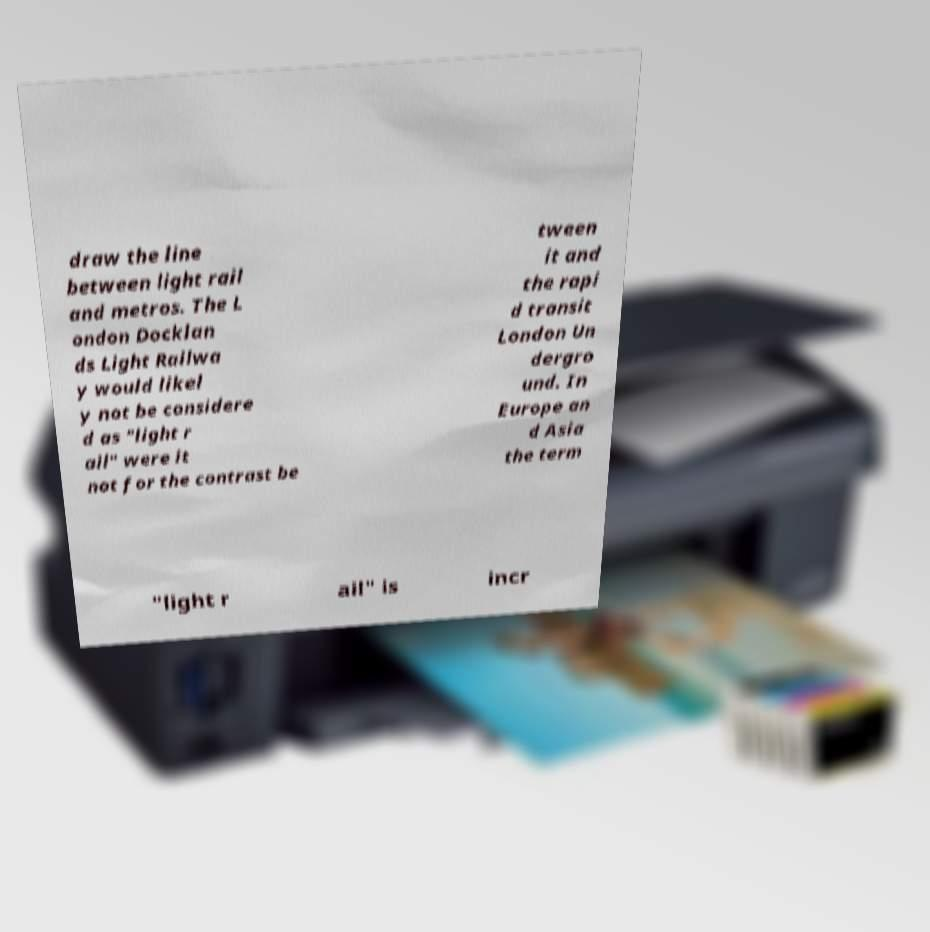There's text embedded in this image that I need extracted. Can you transcribe it verbatim? draw the line between light rail and metros. The L ondon Docklan ds Light Railwa y would likel y not be considere d as "light r ail" were it not for the contrast be tween it and the rapi d transit London Un dergro und. In Europe an d Asia the term "light r ail" is incr 